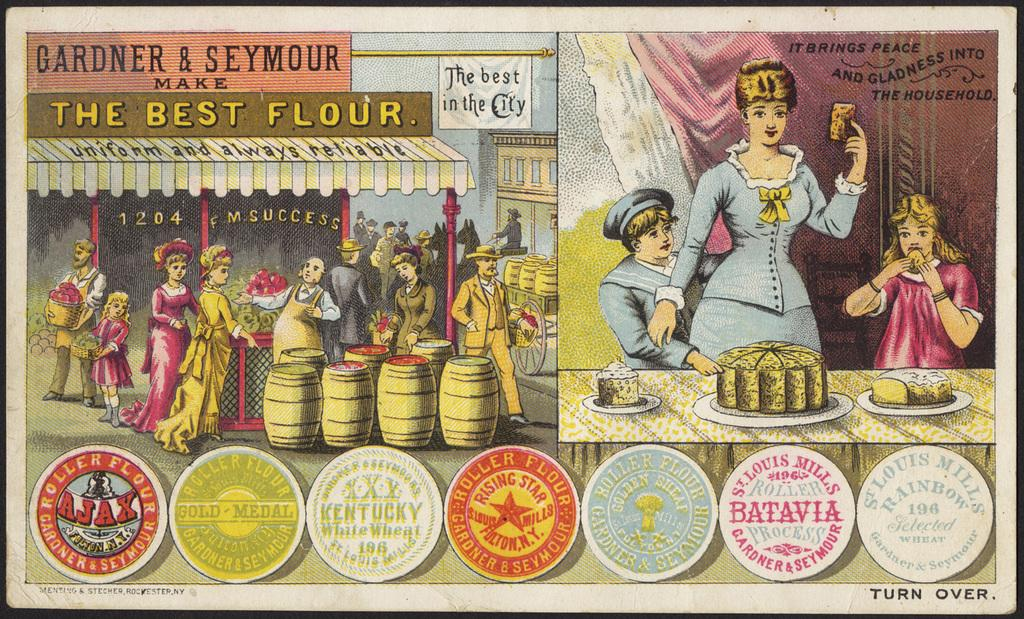Provide a one-sentence caption for the provided image. An advertisement for Gardner and Seymour saying they make the best flour. 